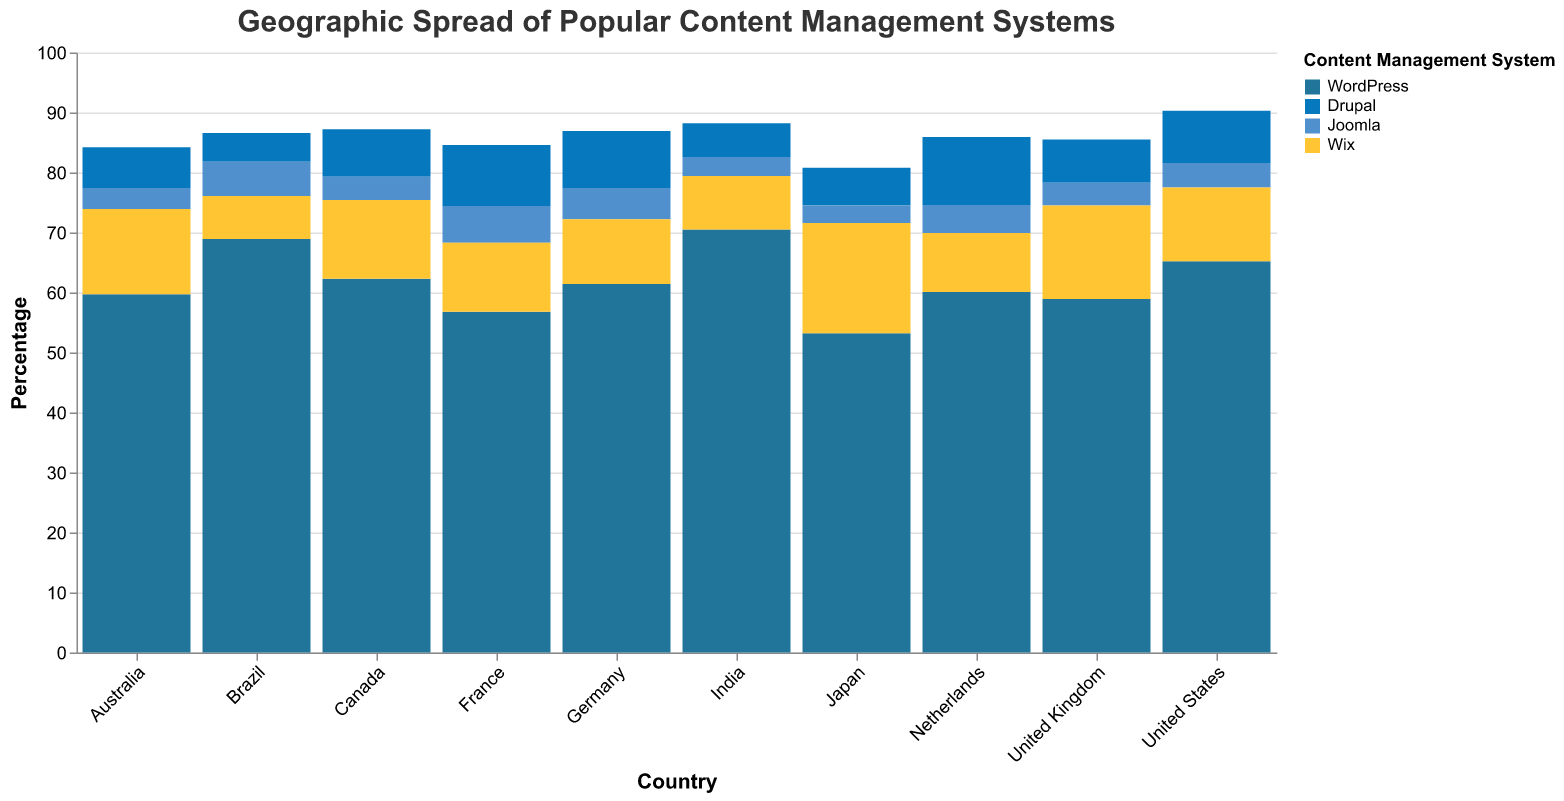What is the title of this figure? The title is placed at the top of the figure and reads "Geographic Spread of Popular Content Management Systems".
Answer: Geographic Spread of Popular Content Management Systems Which CMS is most used in India? Look for India's data and then locate the highest percentage which corresponds to a CMS name. In India, WordPress has the highest percentage at 70.5%.
Answer: WordPress What is the least used CMS in Japan? Locate the data for Japan and find the CMS with the lowest percentage. In Japan, Joomla is the least used at 2.9%.
Answer: Joomla Which country has the highest percentage of WordPress usage? Compare the WordPress percentages across all countries. India has the highest percentage with 70.5%.
Answer: India How do WordPress and Wix compare in terms of usage in the United States? Locate the data for the United States. WordPress is at 65.2% and Wix is at 12.3%. WordPress is significantly more used than Wix.
Answer: WordPress is more used than Wix Which country uses Drupal the most? Look through the percentages for Drupal in each country. The Netherlands has the highest percentage at 11.3%.
Answer: Netherlands What is the sum of Joomla usage percentages for Germany, France, and Brazil? Add up Joomla percentages from the specified countries: Germany (5.2), France (6.1), and Brazil (5.7). The sum is 5.2 + 6.1 + 5.7 = 17.
Answer: 17 Between the United Kingdom and Australia, which country has a higher usage of Wix and by how much? Compare the Wix percentages between the UK (15.6%) and Australia (14.2%). The difference is 15.6 - 14.2 = 1.4%.
Answer: United Kingdom by 1.4% What is the average usage percentage of Drupal across all listed countries? Add Drupal percentages for all countries (8.7, 7.2, 9.5, 6.8, 7.9, 10.2, 11.3, 5.6, 4.8, 6.3), sum is 78.3. There are 10 countries, so the average is 78.3 / 10 = 7.83.
Answer: 7.83% Which CMS has the widest range of usage percentages across all countries? Calculate the range (max - min) for each CMS. WordPress ranges from 53.2 to 70.5 (17.3), Drupal from 4.8 to 11.3 (6.5), Joomla from 2.9 to 6.1 (3.2), and Wix from 7.2 to 18.4 (11.2). WordPress has the widest range.
Answer: WordPress 